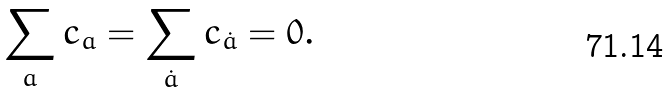Convert formula to latex. <formula><loc_0><loc_0><loc_500><loc_500>\sum _ { a } c _ { a } = \sum _ { \dot { a } } c _ { \dot { a } } = 0 .</formula> 